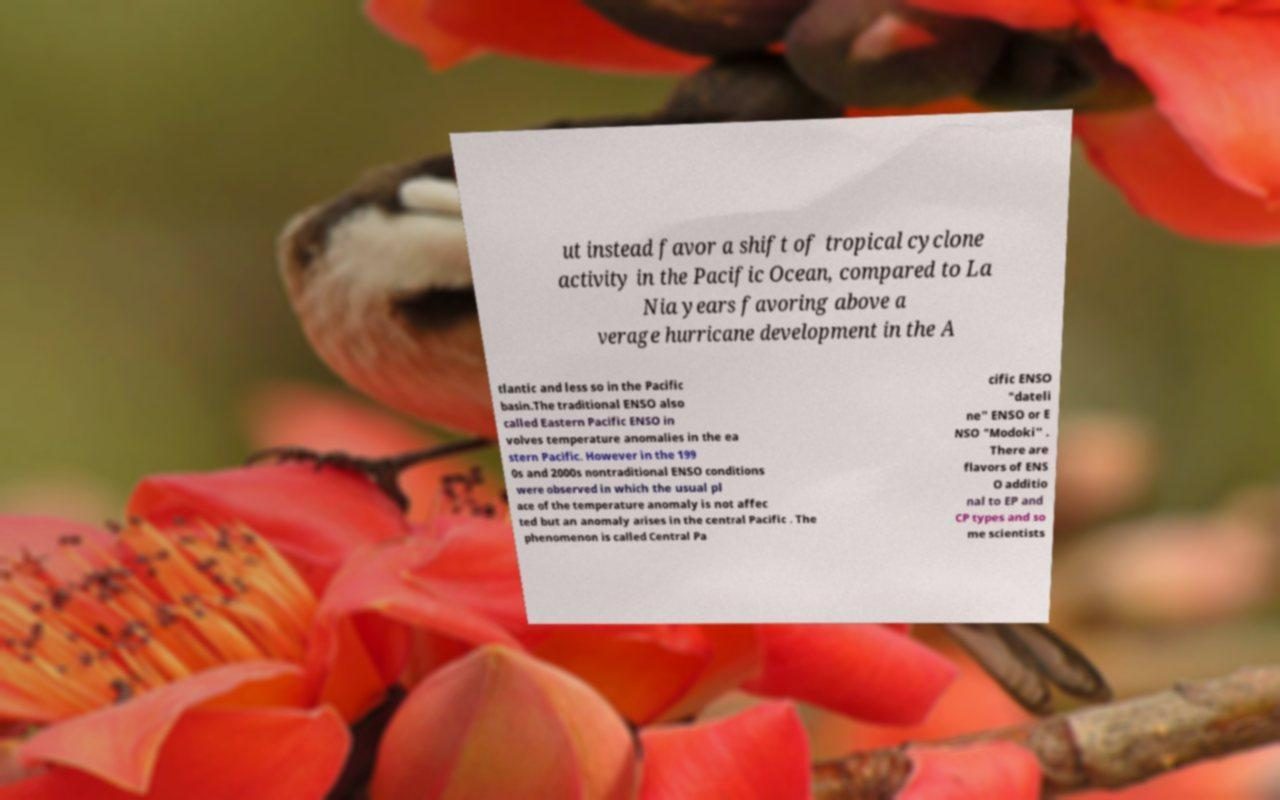Can you accurately transcribe the text from the provided image for me? ut instead favor a shift of tropical cyclone activity in the Pacific Ocean, compared to La Nia years favoring above a verage hurricane development in the A tlantic and less so in the Pacific basin.The traditional ENSO also called Eastern Pacific ENSO in volves temperature anomalies in the ea stern Pacific. However in the 199 0s and 2000s nontraditional ENSO conditions were observed in which the usual pl ace of the temperature anomaly is not affec ted but an anomaly arises in the central Pacific . The phenomenon is called Central Pa cific ENSO "dateli ne" ENSO or E NSO "Modoki" . There are flavors of ENS O additio nal to EP and CP types and so me scientists 